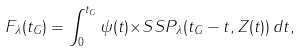<formula> <loc_0><loc_0><loc_500><loc_500>F _ { \lambda } ( t _ { G } ) = \int _ { 0 } ^ { t _ { G } } { \psi } ( t ) { \times } { S S P _ { \lambda } } ( t _ { G } - t , Z ( t ) ) \, d t ,</formula> 